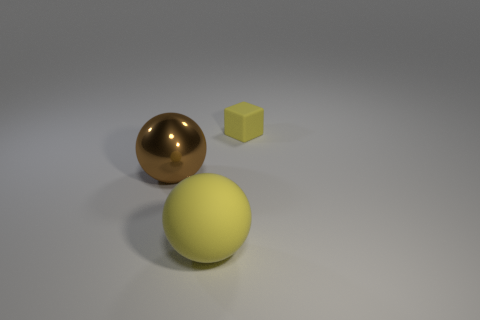How big is the yellow thing behind the brown shiny thing?
Give a very brief answer. Small. Is the size of the brown metal ball the same as the yellow thing that is behind the yellow rubber sphere?
Offer a terse response. No. Are there fewer small yellow things to the left of the large yellow matte ball than large brown objects?
Your answer should be very brief. Yes. What material is the other thing that is the same shape as the brown thing?
Offer a terse response. Rubber. There is a thing that is on the right side of the shiny thing and in front of the small object; what is its shape?
Offer a terse response. Sphere. There is a small object that is the same material as the yellow sphere; what is its shape?
Your answer should be compact. Cube. What is the sphere to the right of the big metal ball made of?
Provide a succinct answer. Rubber. Is the size of the sphere that is in front of the brown sphere the same as the brown metallic sphere on the left side of the small thing?
Your answer should be compact. Yes. What is the color of the block?
Provide a short and direct response. Yellow. Is the shape of the yellow matte thing behind the big rubber sphere the same as  the big yellow thing?
Provide a succinct answer. No. 